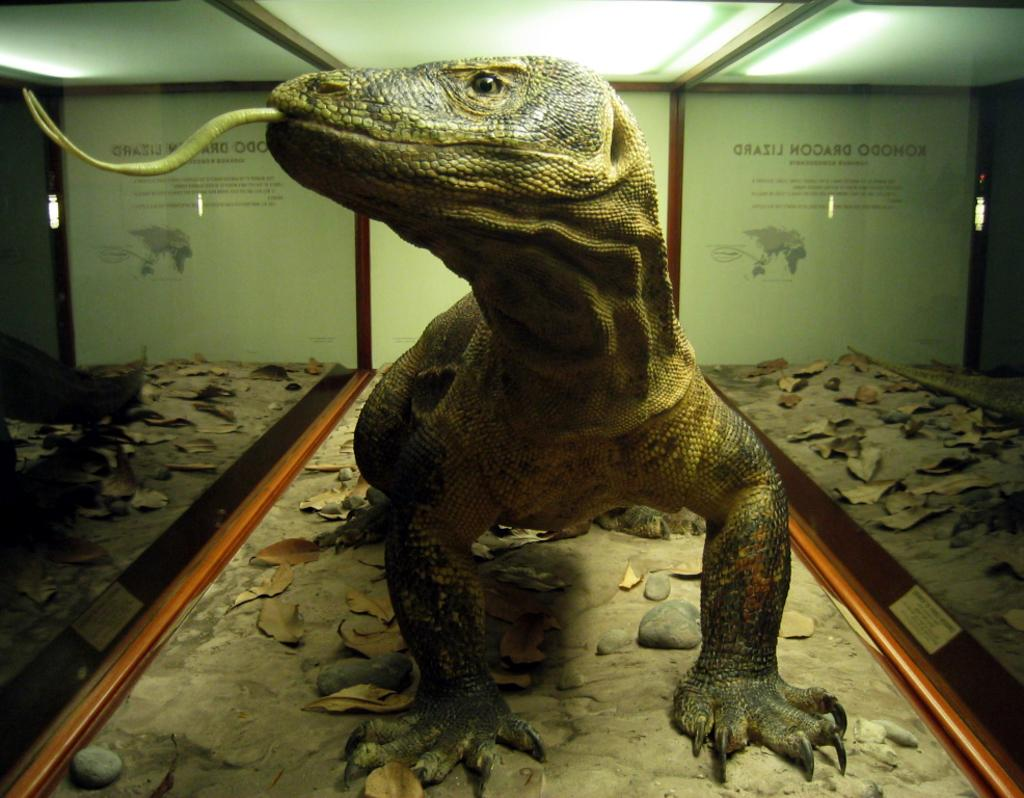What is the main subject of the image? There is a sculpture in the image. What type of sculpture is it? The sculpture is of an animal. Where is the sculpture located? The sculpture is inside a box. What type of harmony can be heard coming from the cannon in the image? There is no cannon present in the image, and therefore no sound can be heard. 